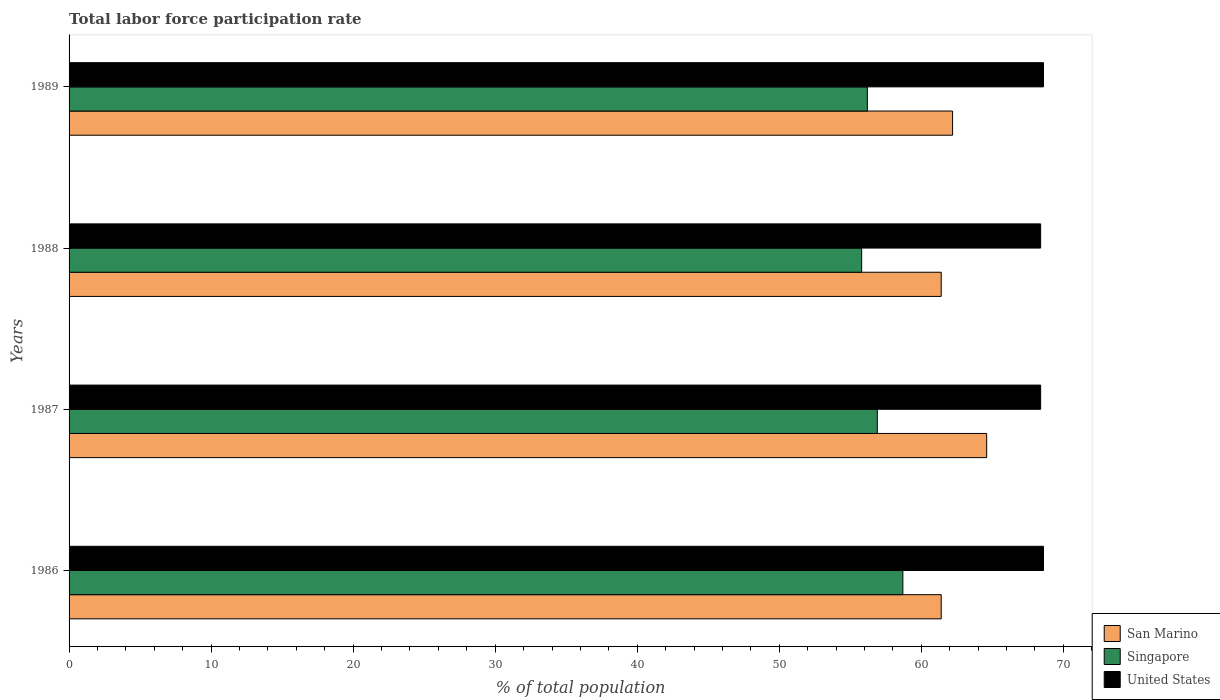How many different coloured bars are there?
Provide a succinct answer. 3. How many groups of bars are there?
Make the answer very short. 4. What is the total labor force participation rate in United States in 1986?
Your response must be concise. 68.6. Across all years, what is the maximum total labor force participation rate in United States?
Your answer should be compact. 68.6. Across all years, what is the minimum total labor force participation rate in Singapore?
Offer a terse response. 55.8. In which year was the total labor force participation rate in San Marino maximum?
Make the answer very short. 1987. In which year was the total labor force participation rate in Singapore minimum?
Provide a short and direct response. 1988. What is the total total labor force participation rate in United States in the graph?
Give a very brief answer. 274. What is the difference between the total labor force participation rate in Singapore in 1986 and that in 1989?
Make the answer very short. 2.5. What is the difference between the total labor force participation rate in United States in 1988 and the total labor force participation rate in San Marino in 1986?
Your answer should be compact. 7. What is the average total labor force participation rate in San Marino per year?
Provide a short and direct response. 62.4. In the year 1988, what is the difference between the total labor force participation rate in United States and total labor force participation rate in Singapore?
Provide a succinct answer. 12.6. In how many years, is the total labor force participation rate in Singapore greater than 54 %?
Ensure brevity in your answer.  4. What is the ratio of the total labor force participation rate in United States in 1986 to that in 1987?
Make the answer very short. 1. Is the total labor force participation rate in San Marino in 1986 less than that in 1987?
Make the answer very short. Yes. Is the difference between the total labor force participation rate in United States in 1988 and 1989 greater than the difference between the total labor force participation rate in Singapore in 1988 and 1989?
Ensure brevity in your answer.  Yes. What is the difference between the highest and the second highest total labor force participation rate in Singapore?
Give a very brief answer. 1.8. What is the difference between the highest and the lowest total labor force participation rate in San Marino?
Keep it short and to the point. 3.2. In how many years, is the total labor force participation rate in San Marino greater than the average total labor force participation rate in San Marino taken over all years?
Offer a very short reply. 1. Is the sum of the total labor force participation rate in San Marino in 1986 and 1988 greater than the maximum total labor force participation rate in United States across all years?
Offer a terse response. Yes. What does the 1st bar from the top in 1988 represents?
Ensure brevity in your answer.  United States. What does the 2nd bar from the bottom in 1989 represents?
Your response must be concise. Singapore. How many bars are there?
Make the answer very short. 12. Does the graph contain any zero values?
Offer a terse response. No. How are the legend labels stacked?
Make the answer very short. Vertical. What is the title of the graph?
Offer a terse response. Total labor force participation rate. What is the label or title of the X-axis?
Ensure brevity in your answer.  % of total population. What is the % of total population in San Marino in 1986?
Give a very brief answer. 61.4. What is the % of total population in Singapore in 1986?
Keep it short and to the point. 58.7. What is the % of total population in United States in 1986?
Your response must be concise. 68.6. What is the % of total population of San Marino in 1987?
Your answer should be compact. 64.6. What is the % of total population in Singapore in 1987?
Ensure brevity in your answer.  56.9. What is the % of total population in United States in 1987?
Your answer should be compact. 68.4. What is the % of total population in San Marino in 1988?
Give a very brief answer. 61.4. What is the % of total population of Singapore in 1988?
Provide a succinct answer. 55.8. What is the % of total population of United States in 1988?
Offer a terse response. 68.4. What is the % of total population of San Marino in 1989?
Your answer should be compact. 62.2. What is the % of total population in Singapore in 1989?
Offer a very short reply. 56.2. What is the % of total population of United States in 1989?
Your answer should be very brief. 68.6. Across all years, what is the maximum % of total population of San Marino?
Your response must be concise. 64.6. Across all years, what is the maximum % of total population of Singapore?
Provide a short and direct response. 58.7. Across all years, what is the maximum % of total population in United States?
Keep it short and to the point. 68.6. Across all years, what is the minimum % of total population of San Marino?
Your response must be concise. 61.4. Across all years, what is the minimum % of total population of Singapore?
Make the answer very short. 55.8. Across all years, what is the minimum % of total population of United States?
Make the answer very short. 68.4. What is the total % of total population in San Marino in the graph?
Keep it short and to the point. 249.6. What is the total % of total population of Singapore in the graph?
Offer a very short reply. 227.6. What is the total % of total population of United States in the graph?
Give a very brief answer. 274. What is the difference between the % of total population in Singapore in 1986 and that in 1987?
Provide a short and direct response. 1.8. What is the difference between the % of total population in United States in 1986 and that in 1987?
Keep it short and to the point. 0.2. What is the difference between the % of total population of San Marino in 1986 and that in 1988?
Make the answer very short. 0. What is the difference between the % of total population of Singapore in 1986 and that in 1988?
Offer a very short reply. 2.9. What is the difference between the % of total population in San Marino in 1986 and that in 1989?
Your answer should be very brief. -0.8. What is the difference between the % of total population in Singapore in 1986 and that in 1989?
Make the answer very short. 2.5. What is the difference between the % of total population of United States in 1986 and that in 1989?
Provide a short and direct response. 0. What is the difference between the % of total population in San Marino in 1987 and that in 1988?
Keep it short and to the point. 3.2. What is the difference between the % of total population in Singapore in 1987 and that in 1988?
Your response must be concise. 1.1. What is the difference between the % of total population in San Marino in 1987 and that in 1989?
Give a very brief answer. 2.4. What is the difference between the % of total population of San Marino in 1988 and that in 1989?
Keep it short and to the point. -0.8. What is the difference between the % of total population of Singapore in 1988 and that in 1989?
Provide a short and direct response. -0.4. What is the difference between the % of total population of San Marino in 1986 and the % of total population of Singapore in 1987?
Ensure brevity in your answer.  4.5. What is the difference between the % of total population in San Marino in 1986 and the % of total population in United States in 1988?
Make the answer very short. -7. What is the difference between the % of total population in Singapore in 1986 and the % of total population in United States in 1988?
Keep it short and to the point. -9.7. What is the difference between the % of total population in San Marino in 1986 and the % of total population in United States in 1989?
Keep it short and to the point. -7.2. What is the difference between the % of total population of San Marino in 1987 and the % of total population of Singapore in 1988?
Your response must be concise. 8.8. What is the difference between the % of total population in San Marino in 1987 and the % of total population in Singapore in 1989?
Offer a very short reply. 8.4. What is the difference between the % of total population of Singapore in 1988 and the % of total population of United States in 1989?
Make the answer very short. -12.8. What is the average % of total population in San Marino per year?
Give a very brief answer. 62.4. What is the average % of total population in Singapore per year?
Your answer should be very brief. 56.9. What is the average % of total population of United States per year?
Offer a terse response. 68.5. In the year 1986, what is the difference between the % of total population of San Marino and % of total population of Singapore?
Give a very brief answer. 2.7. In the year 1986, what is the difference between the % of total population in San Marino and % of total population in United States?
Provide a short and direct response. -7.2. In the year 1987, what is the difference between the % of total population of San Marino and % of total population of Singapore?
Provide a succinct answer. 7.7. In the year 1989, what is the difference between the % of total population in San Marino and % of total population in Singapore?
Offer a very short reply. 6. In the year 1989, what is the difference between the % of total population in San Marino and % of total population in United States?
Give a very brief answer. -6.4. What is the ratio of the % of total population of San Marino in 1986 to that in 1987?
Provide a short and direct response. 0.95. What is the ratio of the % of total population of Singapore in 1986 to that in 1987?
Provide a short and direct response. 1.03. What is the ratio of the % of total population in San Marino in 1986 to that in 1988?
Offer a very short reply. 1. What is the ratio of the % of total population in Singapore in 1986 to that in 1988?
Give a very brief answer. 1.05. What is the ratio of the % of total population in San Marino in 1986 to that in 1989?
Your answer should be very brief. 0.99. What is the ratio of the % of total population of Singapore in 1986 to that in 1989?
Make the answer very short. 1.04. What is the ratio of the % of total population of United States in 1986 to that in 1989?
Offer a terse response. 1. What is the ratio of the % of total population of San Marino in 1987 to that in 1988?
Your answer should be very brief. 1.05. What is the ratio of the % of total population in Singapore in 1987 to that in 1988?
Keep it short and to the point. 1.02. What is the ratio of the % of total population of San Marino in 1987 to that in 1989?
Offer a terse response. 1.04. What is the ratio of the % of total population of Singapore in 1987 to that in 1989?
Your answer should be compact. 1.01. What is the ratio of the % of total population of San Marino in 1988 to that in 1989?
Provide a short and direct response. 0.99. What is the ratio of the % of total population of United States in 1988 to that in 1989?
Your answer should be very brief. 1. What is the difference between the highest and the second highest % of total population of Singapore?
Ensure brevity in your answer.  1.8. What is the difference between the highest and the lowest % of total population in San Marino?
Offer a very short reply. 3.2. What is the difference between the highest and the lowest % of total population of Singapore?
Provide a succinct answer. 2.9. What is the difference between the highest and the lowest % of total population of United States?
Offer a terse response. 0.2. 